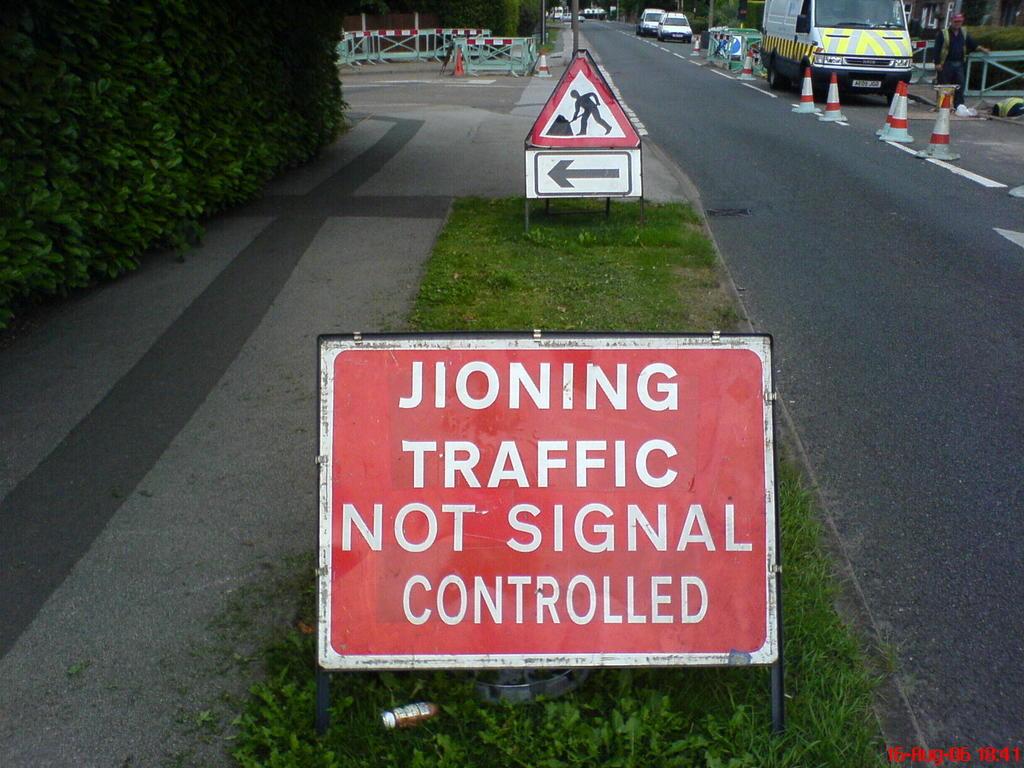What are the words on the sign?
Keep it short and to the point. Jioning traffic not signal controlled. What is not signal controlled, according to the sign?
Offer a very short reply. Jioning traffic. 